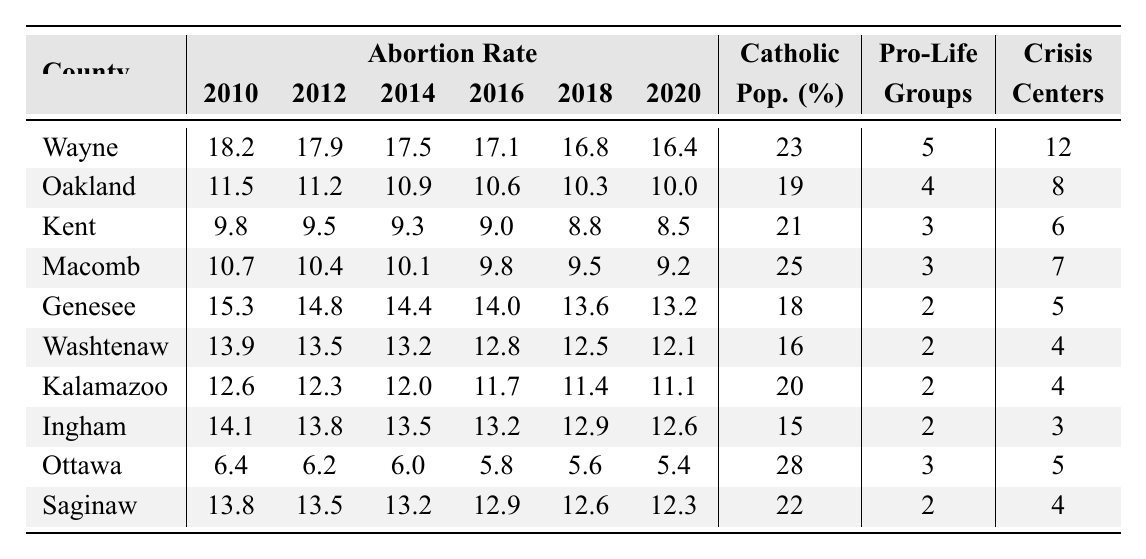What county had the highest abortion rate in 2010? The table shows that Wayne County had an abortion rate of 18.2 in 2010, which is the highest among all listed counties.
Answer: Wayne What was the abortion rate in Ottawa County in 2020? According to the table, Ottawa County had an abortion rate of 5.4 in 2020.
Answer: 5.4 Which county has the largest percentage of Catholic population? Looking at the "Catholic Population Percentage" column, Ottawa County has the largest percentage at 28%.
Answer: Ottawa What is the difference between the abortion rates in Saginaw County from 2010 to 2020? Saginaw County's abortion rate decreased from 13.8 in 2010 to 12.3 in 2020, resulting in a difference of 1.5.
Answer: 1.5 Which counties saw an abortion rate decrease from 2010 to 2020 and what was the rate in Kent County in 2018? The counties that saw a reduction from 2010 to 2020 are Wayne, Oakland, Kent, Macomb, Genesee, Washtenaw, Kalamazoo, Ingham, Ottawa, and Saginaw. Kent County's rate in 2018 was 8.8.
Answer: Yes, 8.8 What is the average abortion rate for all counties in 2016? Adding up the abortion rates for all counties in 2016 (17.1 + 10.6 + 9.0 + 9.8 + 14.0 + 12.8 + 11.7 + 13.2 + 5.8 + 12.9) equals 13.1 when divided by 10 counties.
Answer: 13.1 Did Washtenaw County ever have an abortion rate higher than 14 from 2010 to 2020? By examining the table, Washtenaw County had an abortion rate of 13.9 in 2010, which is not higher than 14 in any subsequent years up to 2020.
Answer: No Which county had the highest number of Pro-Life Advocacy Groups? Referring to the "Pro-Life Advocacy Groups" column, Wayne County, with 5 groups, had the highest number.
Answer: Wayne What was the minimum abortion rate recorded in 2014 across the counties? The lowest abortion rate in 2014 was recorded in Kent County with 9.3.
Answer: 9.3 How does the decline in the abortion rate from 2010 to 2020 in Genesee County compare to that in Kalamazoo County? Genesee County's rate fell from 15.3 to 13.2, a decline of 2.1, while Kalamazoo's decreased from 12.6 to 11.1, a decline of 1.5. The decline in Genesee is greater.
Answer: Genesee's decline is greater 